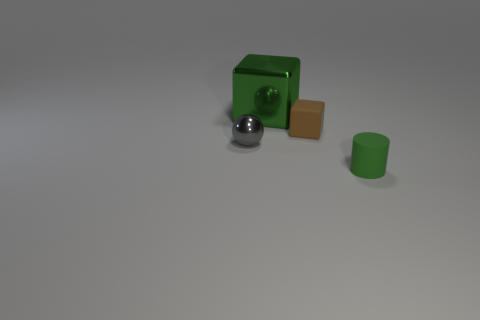Add 1 big objects. How many objects exist? 5 Subtract all spheres. How many objects are left? 3 Subtract 1 green blocks. How many objects are left? 3 Subtract all big gray matte balls. Subtract all small rubber cylinders. How many objects are left? 3 Add 1 metallic balls. How many metallic balls are left? 2 Add 4 small rubber cubes. How many small rubber cubes exist? 5 